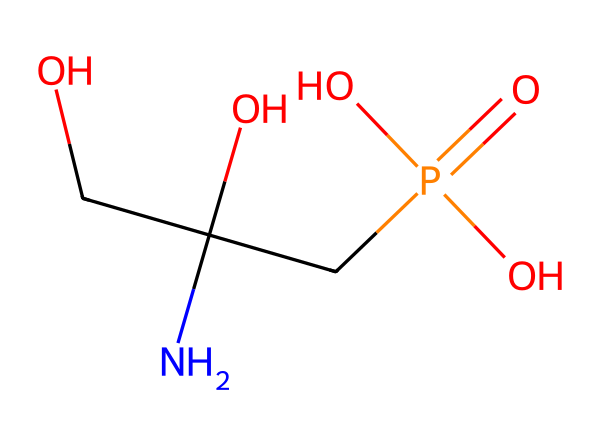What is the functional group present in glyphosate? The chemical structure shows a phosphate group represented by the segment CP(=O)(O)O, which indicates that glyphosate contains this key functional group.
Answer: phosphate How many oxygen atoms are present in glyphosate? By analyzing the chemical structure, we can count a total of four oxygen atoms: three from the phosphate group and one from the alcohol group.
Answer: four What is the total number of carbon atoms in glyphosate? In the structure, there are two carbon atoms in the main chain (OCC) and one in the phosphate group (CP), giving a total of three carbon atoms.
Answer: three Does glyphosate contain a nitrogen atom? Yes, there is a nitrogen atom present in the structure, indicated by the 'N' in the chain OCC(O)(CP(=O)(O)O).
Answer: yes What type of molecule is glyphosate? Glyphosate is an herbicide, which is specifically designed to kill unwanted plants and weeds, showing its chemical classification as a pesticide.
Answer: herbicide What type of bond connects the nitrogen atom to the surrounding structure? The structure indicates a single bond connecting nitrogen to the carbon, as evident from the attachment of the nitrogen (N) to the carbon chain (OCC).
Answer: single bond 